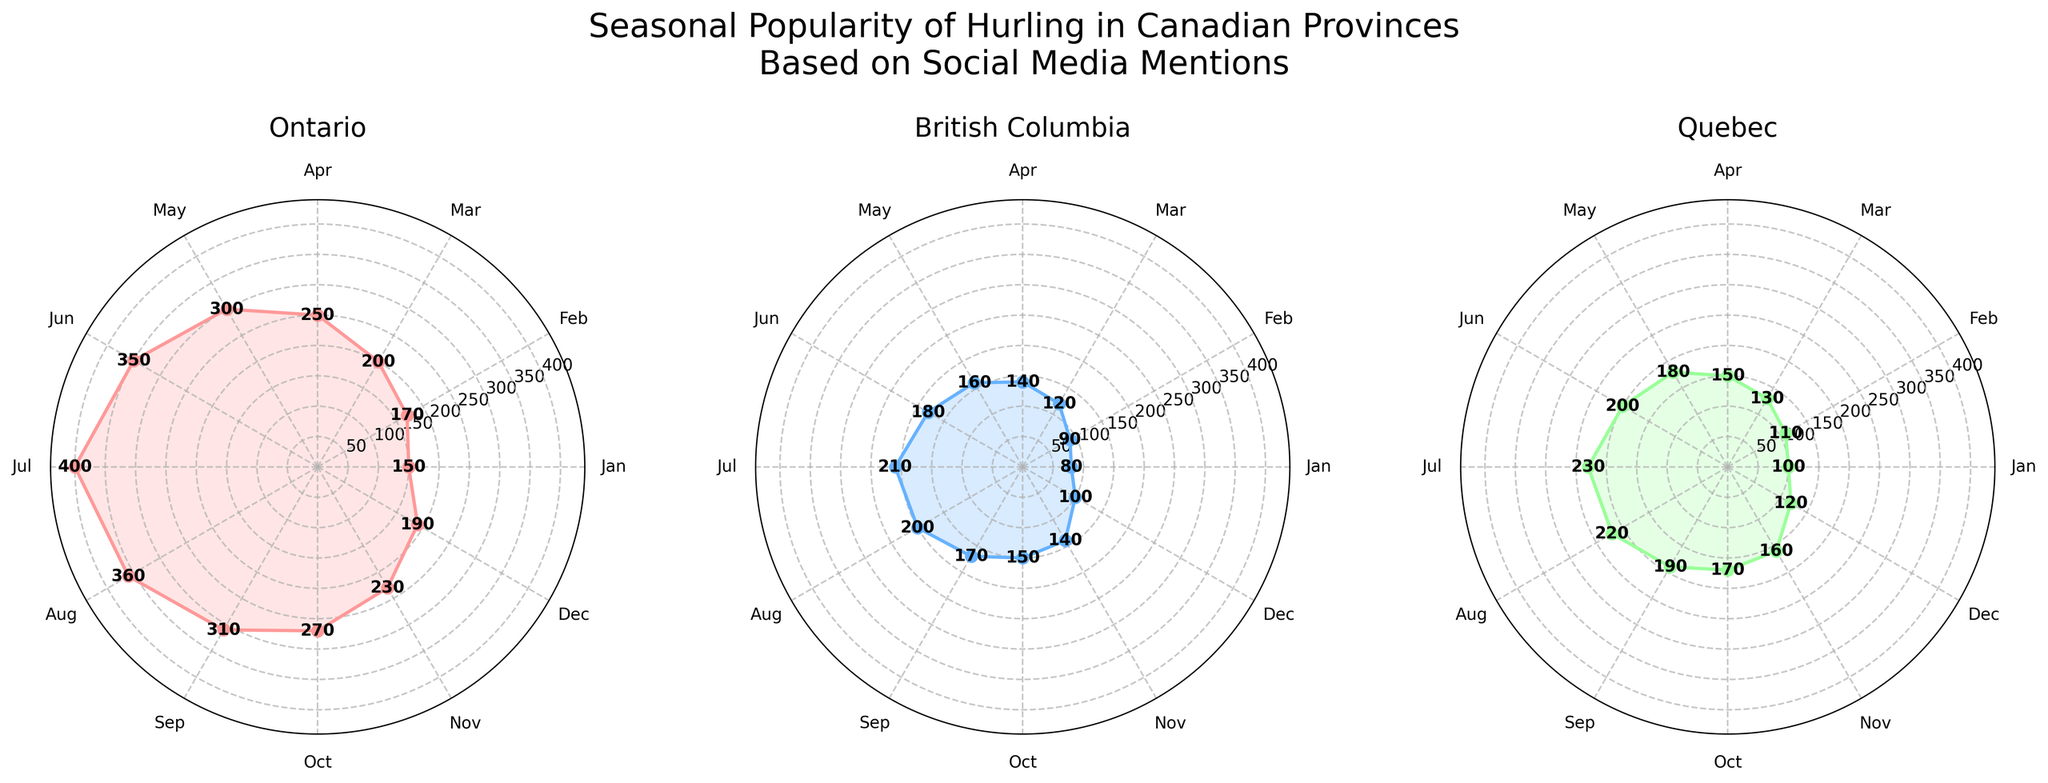What is the title of the figure? The title of the figure is usually found at the top and summarizes the content of the figure; here, it states "Seasonal Popularity of Hurling in Canadian Provinces Based on Social Media Mentions."
Answer: Seasonal Popularity of Hurling in Canadian Provinces Based on Social Media Mentions Which month has the highest number of mentions in Ontario? By examining the plot for Ontario, the highest peak on the radial axis corresponds to July.
Answer: July How do the social media mentions in Quebec compare between January and July? To compare, you check the lengths of the radial lines for January and July in the Quebec subplot. January has 100 mentions, and July has 230 mentions, making July’s mentions higher.
Answer: July has more mentions In which month does British Columbia see its peak in social media mentions for hurling? On the plot for British Columbia, the longest radial line, indicating the highest number of mentions, occurs in July.
Answer: July What is the difference in social media mentions between May and November in Ontario? In Ontario's subplot, the value for May is 300 mentions, and for November, it is 230 mentions. The difference is 300 - 230 = 70.
Answer: 70 Which province has the lowest mentions in December? Checking the subplots, British Columbia shows the shortest radial line in December which corresponds to 100 mentions.
Answer: British Columbia In which month is the popularity of hurling the lowest in Quebec and what are the mentions for that month? In Quebec's subplot, the smallest radial line is in January, which corresponds to 100 mentions.
Answer: January, 100 mentions How does the average number of mentions in April compare between Ontario, British Columbia, and Quebec? Calculate the average in April by summing the values and dividing by the number of provinces: (250 + 140 + 150) / 3 = 540 / 3 = 180.
Answer: 180 In which month does Ontario's social media mentions start to decline after the peak in July? On Ontario's subplot, the mentions start to decline from August after peaking in July.
Answer: August Between Ontario and Quebec, which has a more significant increase in social media mentions from February to March? Ontario's mentions go from 170 in February to 200 in March (increase of 30), and Quebec's from 110 in February to 130 in March (increase of 20). So Ontario has a more significant increase.
Answer: Ontario 